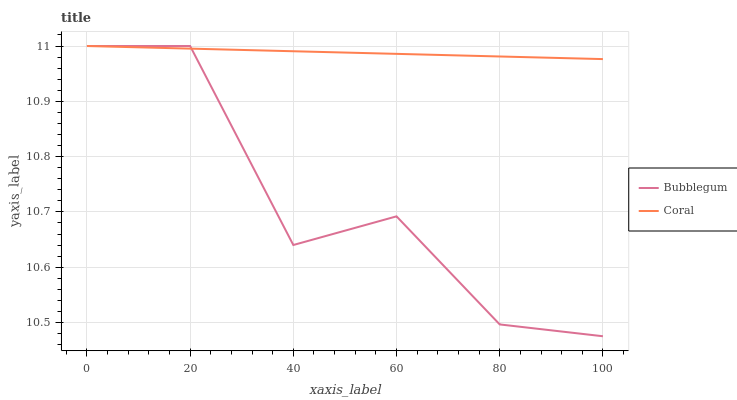Does Bubblegum have the minimum area under the curve?
Answer yes or no. Yes. Does Coral have the maximum area under the curve?
Answer yes or no. Yes. Does Bubblegum have the maximum area under the curve?
Answer yes or no. No. Is Coral the smoothest?
Answer yes or no. Yes. Is Bubblegum the roughest?
Answer yes or no. Yes. Is Bubblegum the smoothest?
Answer yes or no. No. 